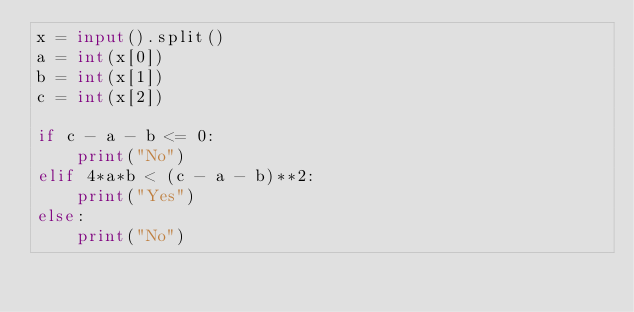Convert code to text. <code><loc_0><loc_0><loc_500><loc_500><_Python_>x = input().split()
a = int(x[0])
b = int(x[1])
c = int(x[2])

if c - a - b <= 0:
    print("No")
elif 4*a*b < (c - a - b)**2:
    print("Yes")
else:
    print("No")</code> 